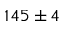<formula> <loc_0><loc_0><loc_500><loc_500>1 4 5 \pm 4</formula> 